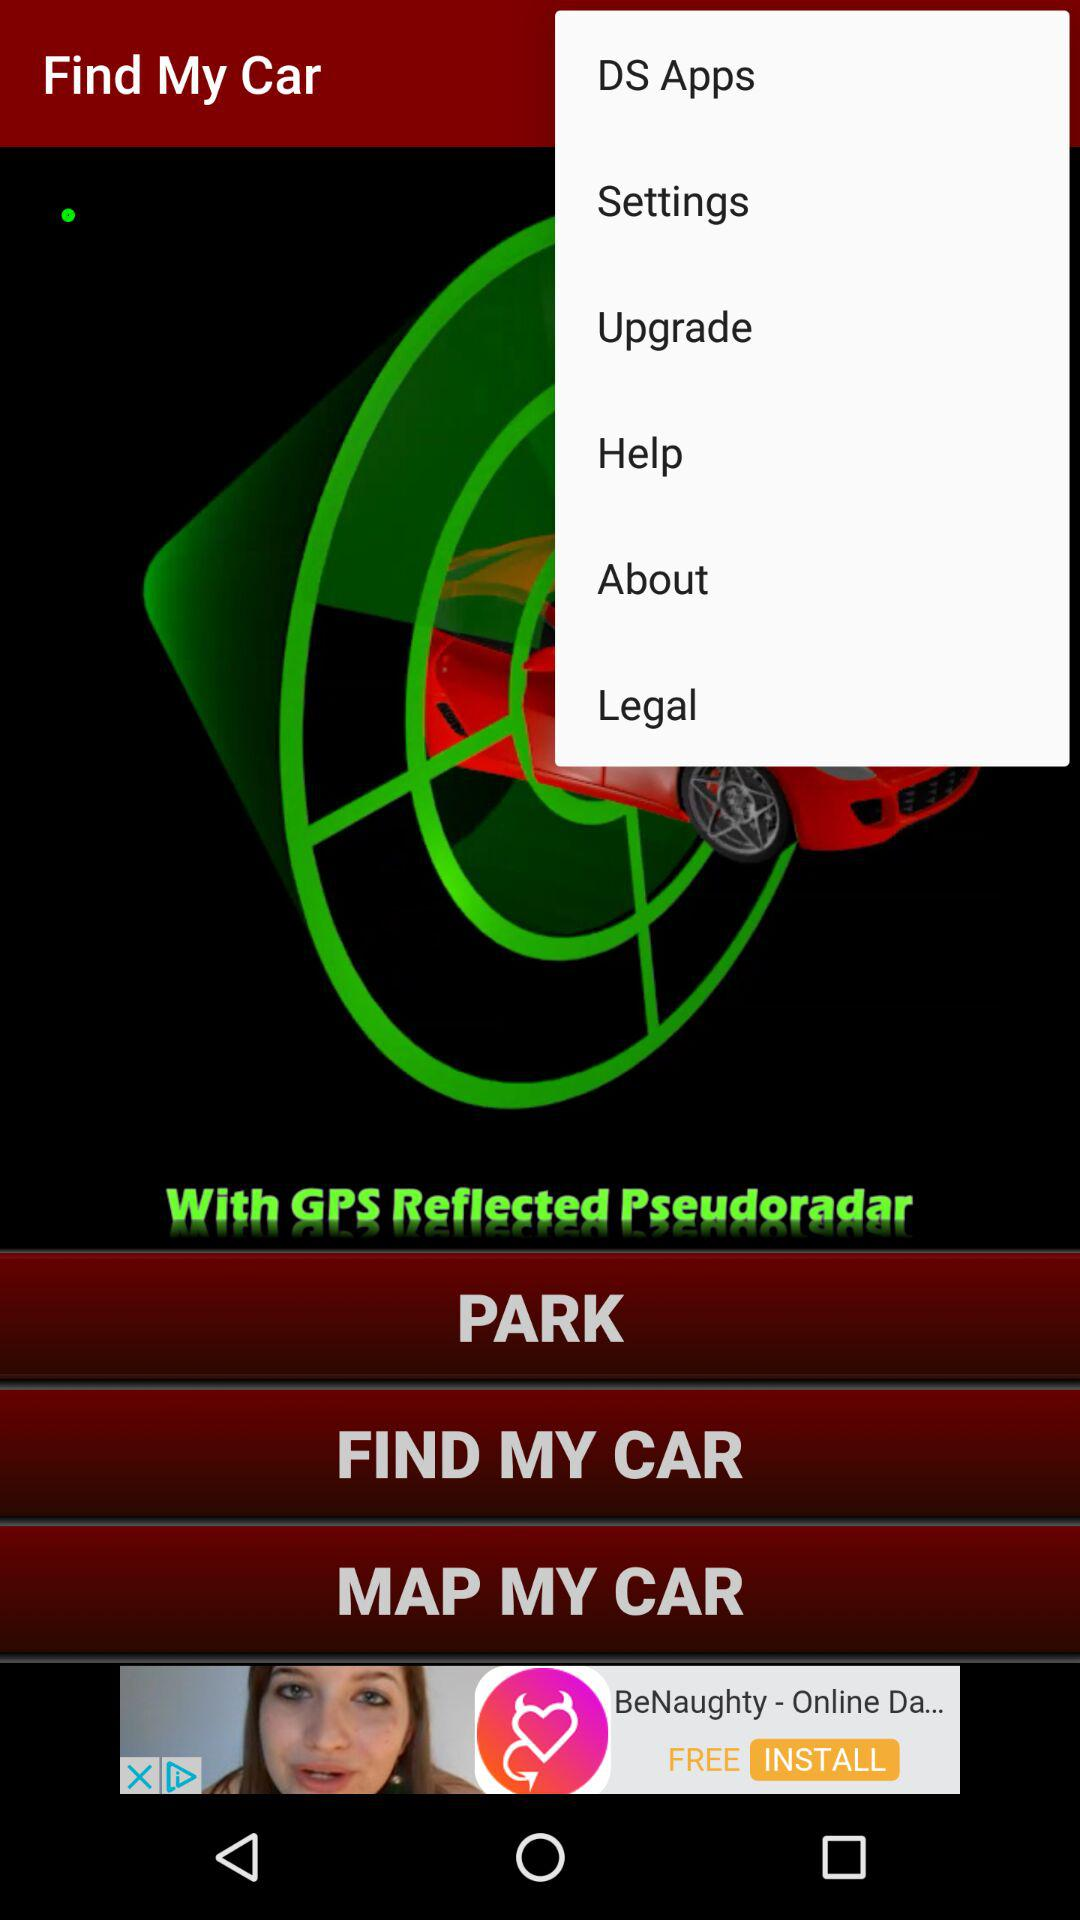What is the name of the application? The name of the application are "Find My Car" and "DS Apps". 